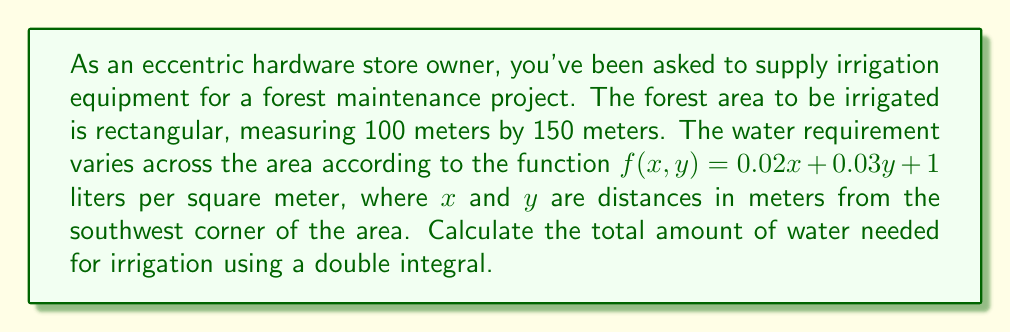Give your solution to this math problem. To solve this problem, we need to set up and evaluate a double integral. Let's approach this step-by-step:

1) The water requirement function is given as:
   $f(x,y) = 0.02x + 0.03y + 1$ liters per square meter

2) The area is rectangular, with dimensions:
   $x$ from 0 to 100 meters
   $y$ from 0 to 150 meters

3) We need to integrate this function over the given area. The double integral will be:

   $$\int_0^{150} \int_0^{100} (0.02x + 0.03y + 1) \, dx \, dy$$

4) Let's solve the inner integral first (with respect to $x$):

   $$\int_0^{150} \left[ \int_0^{100} (0.02x + 0.03y + 1) \, dx \right] \, dy$$
   $$= \int_0^{150} \left[ (0.01x^2 + 0.03yx + x) \bigg|_0^{100} \right] \, dy$$
   $$= \int_0^{150} (100 + 3y + 100) \, dy$$
   $$= \int_0^{150} (200 + 3y) \, dy$$

5) Now let's solve the outer integral:

   $$= \left[ 200y + 1.5y^2 \right]_0^{150}$$
   $$= (30000 + 33750) - (0 + 0)$$
   $$= 63750$$

6) Therefore, the total amount of water needed is 63,750 liters.
Answer: 63,750 liters 